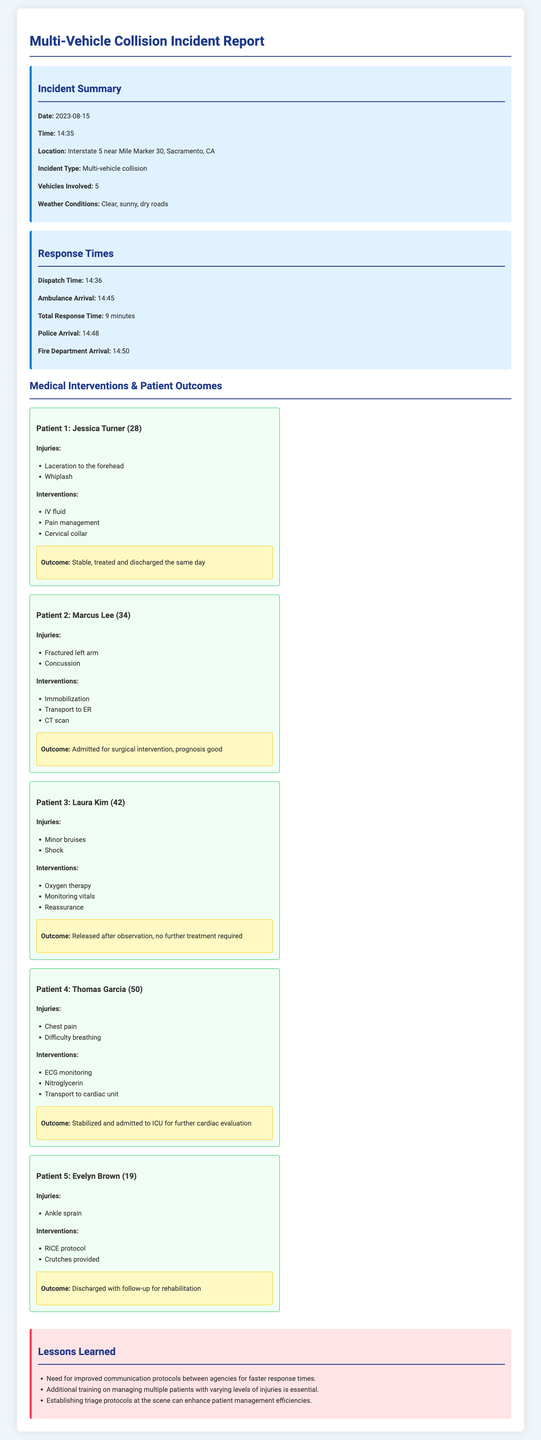What is the incident date? The date of the incident is indicated in the summary section of the document.
Answer: 2023-08-15 What were the weather conditions during the incident? The weather conditions are disclosed in the incident summary.
Answer: Clear, sunny, dry roads What time did the ambulance arrive? The time of ambulance arrival is mentioned under the response times section.
Answer: 14:45 How many vehicles were involved in the collision? The number of vehicles involved is stated in the incident summary.
Answer: 5 What injury did Patient 2 sustain? The injuries sustained by Patient 2 are listed in their patient card.
Answer: Fractured left arm What intervention was performed on Patient 4? The medical interventions for Patient 4 are outlined in the document.
Answer: ECG monitoring What was the outcome for Patient 1? The outcome for Patient 1 can be found in the patient's outcome section.
Answer: Stable, treated and discharged the same day Which agency arrived last at the scene? The arrival times of the agencies are outlined to determine which was last.
Answer: Fire Department What is one lesson learned from the incident? The lessons learned section provides insights into improvements.
Answer: Need for improved communication protocols between agencies for faster response times 